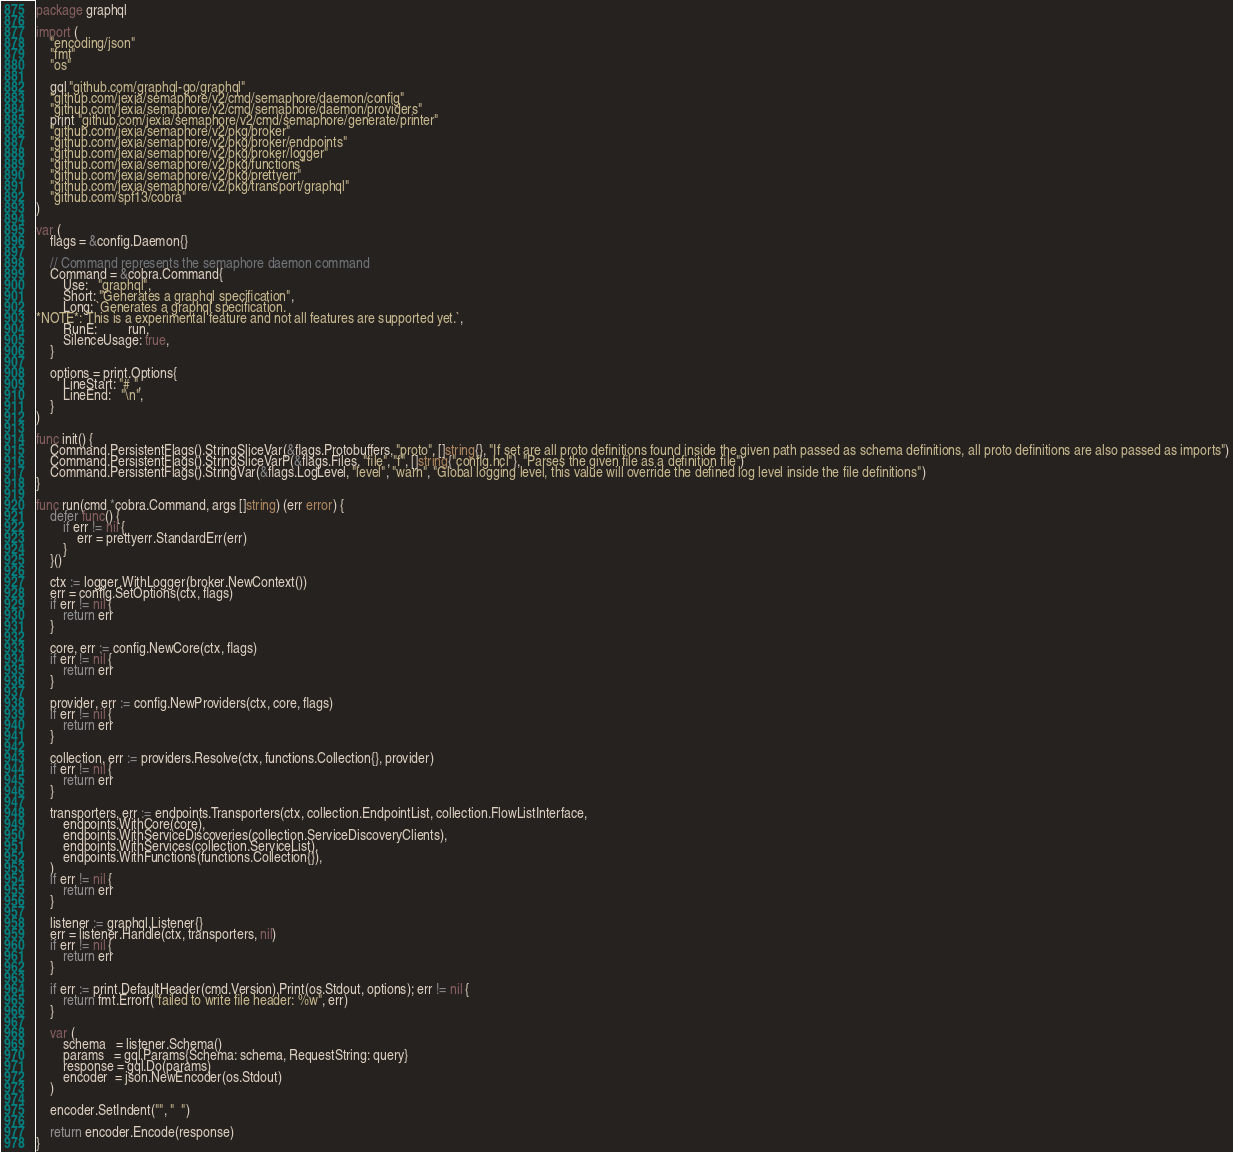Convert code to text. <code><loc_0><loc_0><loc_500><loc_500><_Go_>package graphql

import (
	"encoding/json"
	"fmt"
	"os"

	gql "github.com/graphql-go/graphql"
	"github.com/jexia/semaphore/v2/cmd/semaphore/daemon/config"
	"github.com/jexia/semaphore/v2/cmd/semaphore/daemon/providers"
	print "github.com/jexia/semaphore/v2/cmd/semaphore/generate/printer"
	"github.com/jexia/semaphore/v2/pkg/broker"
	"github.com/jexia/semaphore/v2/pkg/broker/endpoints"
	"github.com/jexia/semaphore/v2/pkg/broker/logger"
	"github.com/jexia/semaphore/v2/pkg/functions"
	"github.com/jexia/semaphore/v2/pkg/prettyerr"
	"github.com/jexia/semaphore/v2/pkg/transport/graphql"
	"github.com/spf13/cobra"
)

var (
	flags = &config.Daemon{}

	// Command represents the semaphore daemon command
	Command = &cobra.Command{
		Use:   "graphql",
		Short: "Generates a graphql specification",
		Long: `Generates a graphql specification.
*NOTE*: This is a experimental feature and not all features are supported yet.`,
		RunE:         run,
		SilenceUsage: true,
	}

	options = print.Options{
		LineStart: "# ",
		LineEnd:   "\n",
	}
)

func init() {
	Command.PersistentFlags().StringSliceVar(&flags.Protobuffers, "proto", []string{}, "If set are all proto definitions found inside the given path passed as schema definitions, all proto definitions are also passed as imports")
	Command.PersistentFlags().StringSliceVarP(&flags.Files, "file", "f", []string{"config.hcl"}, "Parses the given file as a definition file")
	Command.PersistentFlags().StringVar(&flags.LogLevel, "level", "warn", "Global logging level, this value will override the defined log level inside the file definitions")
}

func run(cmd *cobra.Command, args []string) (err error) {
	defer func() {
		if err != nil {
			err = prettyerr.StandardErr(err)
		}
	}()

	ctx := logger.WithLogger(broker.NewContext())
	err = config.SetOptions(ctx, flags)
	if err != nil {
		return err
	}

	core, err := config.NewCore(ctx, flags)
	if err != nil {
		return err
	}

	provider, err := config.NewProviders(ctx, core, flags)
	if err != nil {
		return err
	}

	collection, err := providers.Resolve(ctx, functions.Collection{}, provider)
	if err != nil {
		return err
	}

	transporters, err := endpoints.Transporters(ctx, collection.EndpointList, collection.FlowListInterface,
		endpoints.WithCore(core),
		endpoints.WithServiceDiscoveries(collection.ServiceDiscoveryClients),
		endpoints.WithServices(collection.ServiceList),
		endpoints.WithFunctions(functions.Collection{}),
	)
	if err != nil {
		return err
	}

	listener := graphql.Listener{}
	err = listener.Handle(ctx, transporters, nil)
	if err != nil {
		return err
	}

	if err := print.DefaultHeader(cmd.Version).Print(os.Stdout, options); err != nil {
		return fmt.Errorf("failed to write file header: %w", err)
	}

	var (
		schema   = listener.Schema()
		params   = gql.Params{Schema: schema, RequestString: query}
		response = gql.Do(params)
		encoder  = json.NewEncoder(os.Stdout)
	)

	encoder.SetIndent("", "  ")

	return encoder.Encode(response)
}
</code> 